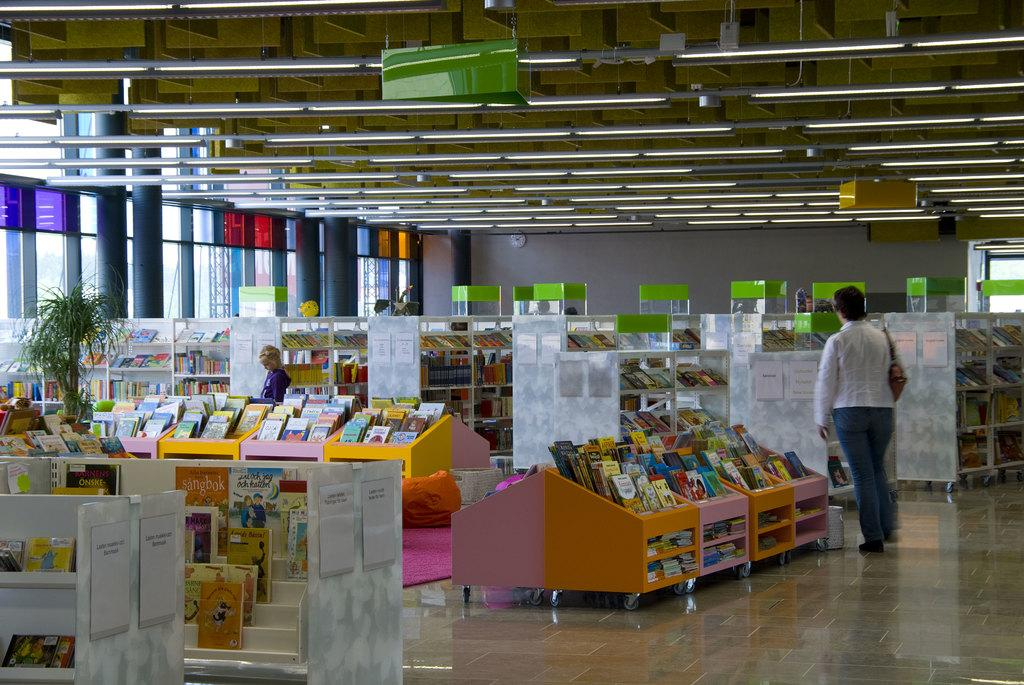What type of place is depicted in the image? The image appears to be a library. What can be found on the shelves in the library? There are books on the shelves in the image. Are there any other objects or decorations in the library? Yes, there is a plant in the image. What else can be seen on the shelves besides books? There are papers with text pasted on the shelves. Is there anyone present in the library? Yes, there is a man standing in the image. How many cows are visible in the library? There are no cows present in the image; it is a library with books, a plant, papers with text, and a man. What type of journey is the man in the image embarking on? There is no indication of a journey in the image; it simply shows a man standing in a library. 